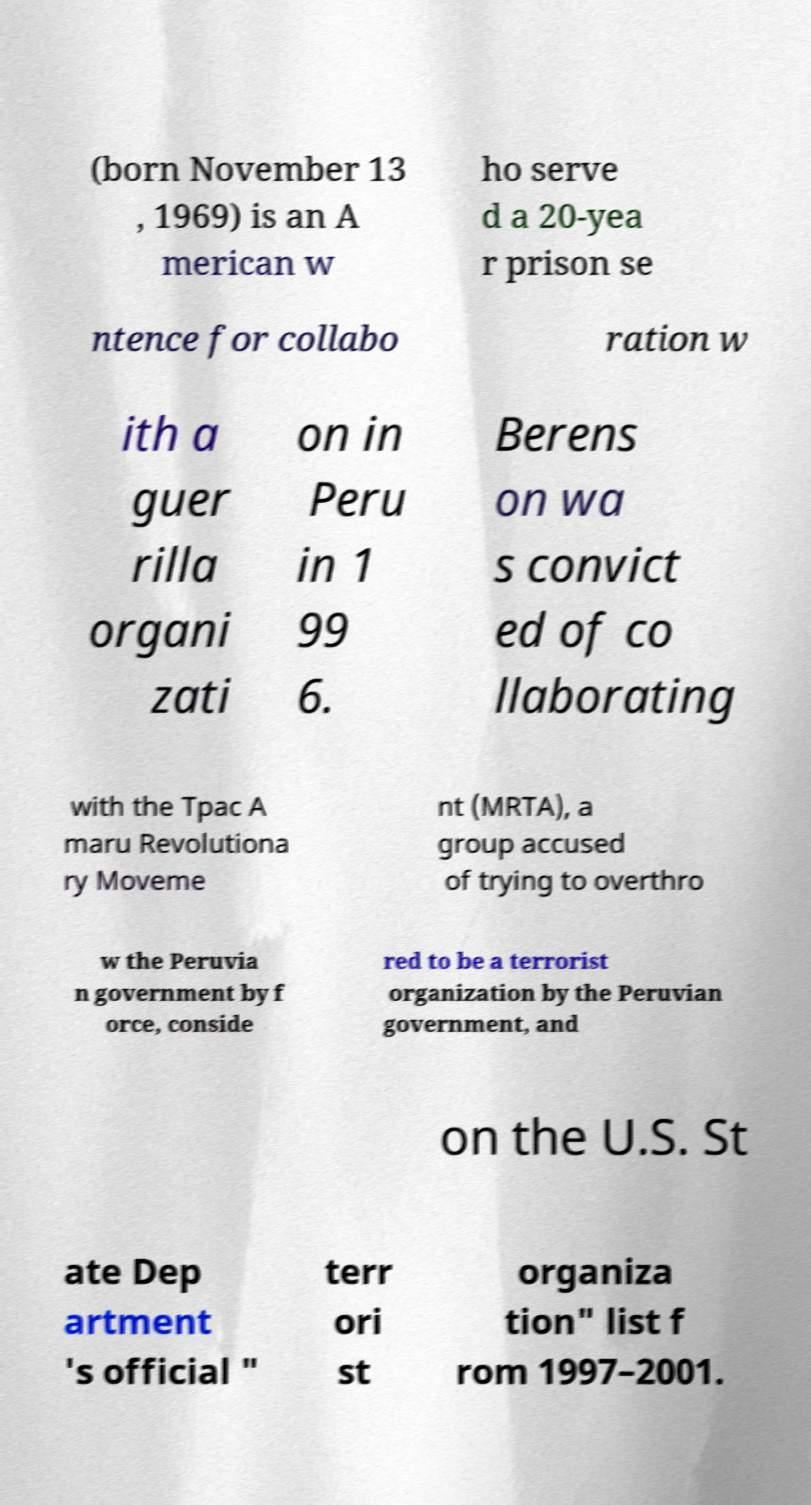Can you accurately transcribe the text from the provided image for me? (born November 13 , 1969) is an A merican w ho serve d a 20-yea r prison se ntence for collabo ration w ith a guer rilla organi zati on in Peru in 1 99 6. Berens on wa s convict ed of co llaborating with the Tpac A maru Revolutiona ry Moveme nt (MRTA), a group accused of trying to overthro w the Peruvia n government by f orce, conside red to be a terrorist organization by the Peruvian government, and on the U.S. St ate Dep artment 's official " terr ori st organiza tion" list f rom 1997–2001. 